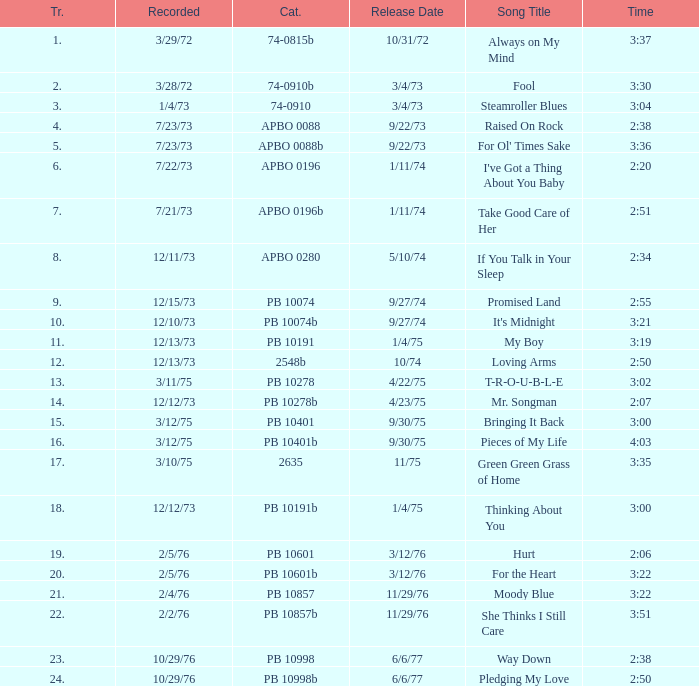Tell me the time for 6/6/77 release date and song title of way down 2:38. 